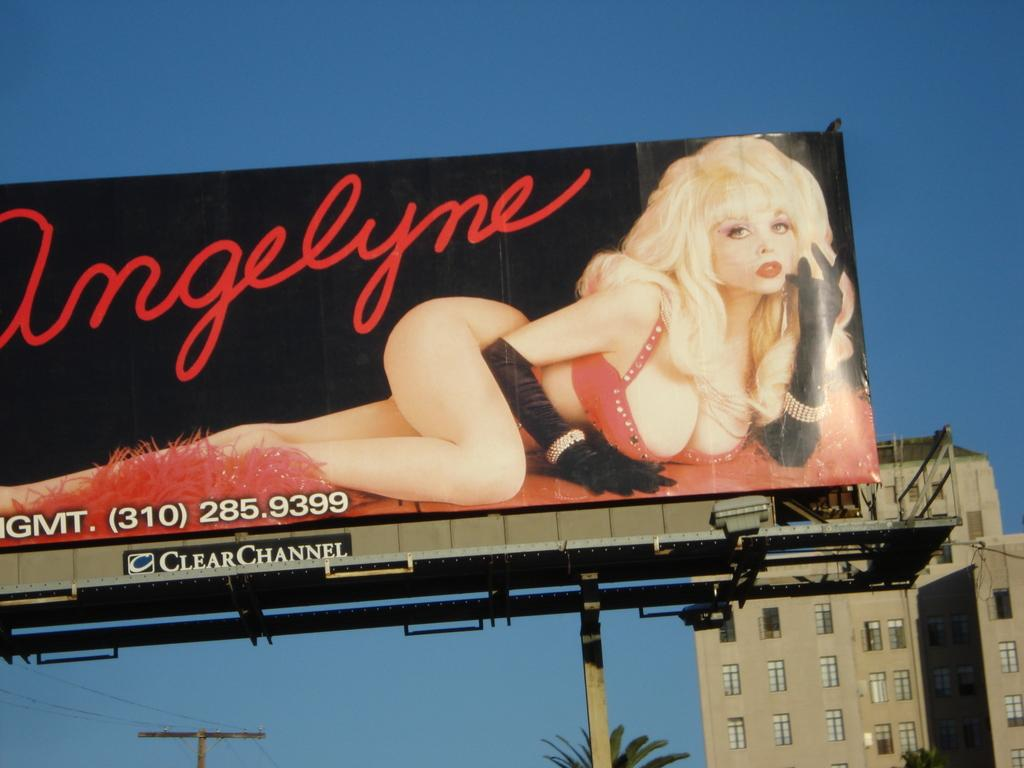<image>
Share a concise interpretation of the image provided. A scantily clad blonde woman is on a giant billboard and says Angelyne in red cursive letters. 